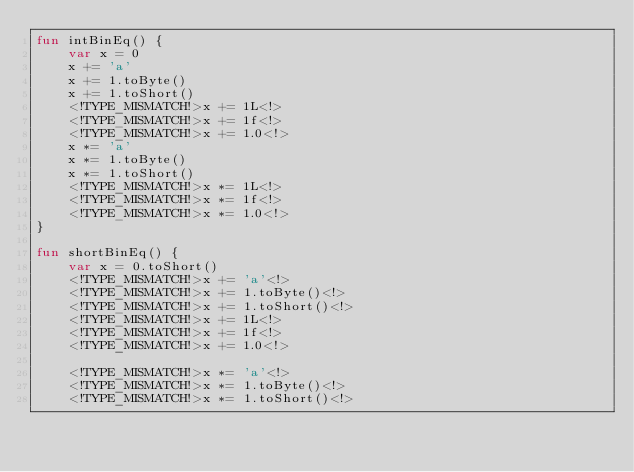Convert code to text. <code><loc_0><loc_0><loc_500><loc_500><_Kotlin_>fun intBinEq() {
    var x = 0
    x += 'a'
    x += 1.toByte()
    x += 1.toShort()
    <!TYPE_MISMATCH!>x += 1L<!>
    <!TYPE_MISMATCH!>x += 1f<!>
    <!TYPE_MISMATCH!>x += 1.0<!>
    x *= 'a'
    x *= 1.toByte()
    x *= 1.toShort()
    <!TYPE_MISMATCH!>x *= 1L<!>
    <!TYPE_MISMATCH!>x *= 1f<!>
    <!TYPE_MISMATCH!>x *= 1.0<!>
}

fun shortBinEq() {
    var x = 0.toShort()
    <!TYPE_MISMATCH!>x += 'a'<!>
    <!TYPE_MISMATCH!>x += 1.toByte()<!>
    <!TYPE_MISMATCH!>x += 1.toShort()<!>
    <!TYPE_MISMATCH!>x += 1L<!>
    <!TYPE_MISMATCH!>x += 1f<!>
    <!TYPE_MISMATCH!>x += 1.0<!>

    <!TYPE_MISMATCH!>x *= 'a'<!>
    <!TYPE_MISMATCH!>x *= 1.toByte()<!>
    <!TYPE_MISMATCH!>x *= 1.toShort()<!></code> 